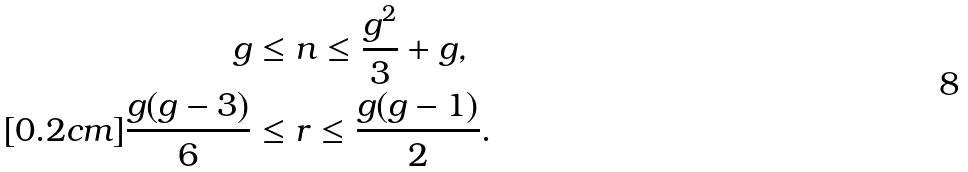Convert formula to latex. <formula><loc_0><loc_0><loc_500><loc_500>g & \leq n \leq \frac { g ^ { 2 } } { 3 } + g , \\ [ 0 . 2 c m ] \frac { g ( g - 3 ) } { 6 } & \leq r \leq \frac { g ( g - 1 ) } { 2 } .</formula> 